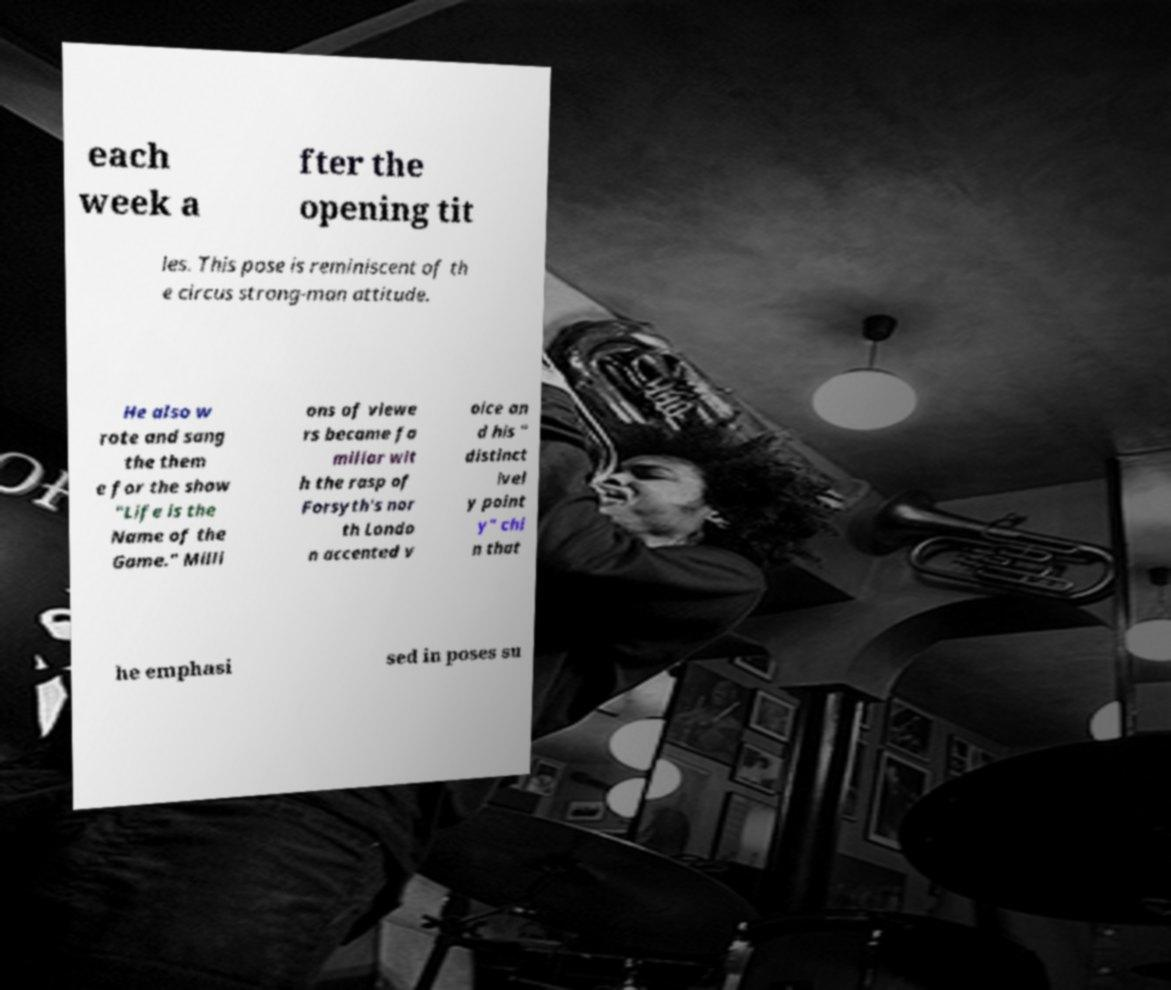What messages or text are displayed in this image? I need them in a readable, typed format. each week a fter the opening tit les. This pose is reminiscent of th e circus strong-man attitude. He also w rote and sang the them e for the show "Life is the Name of the Game." Milli ons of viewe rs became fa miliar wit h the rasp of Forsyth's nor th Londo n accented v oice an d his " distinct ivel y point y" chi n that he emphasi sed in poses su 